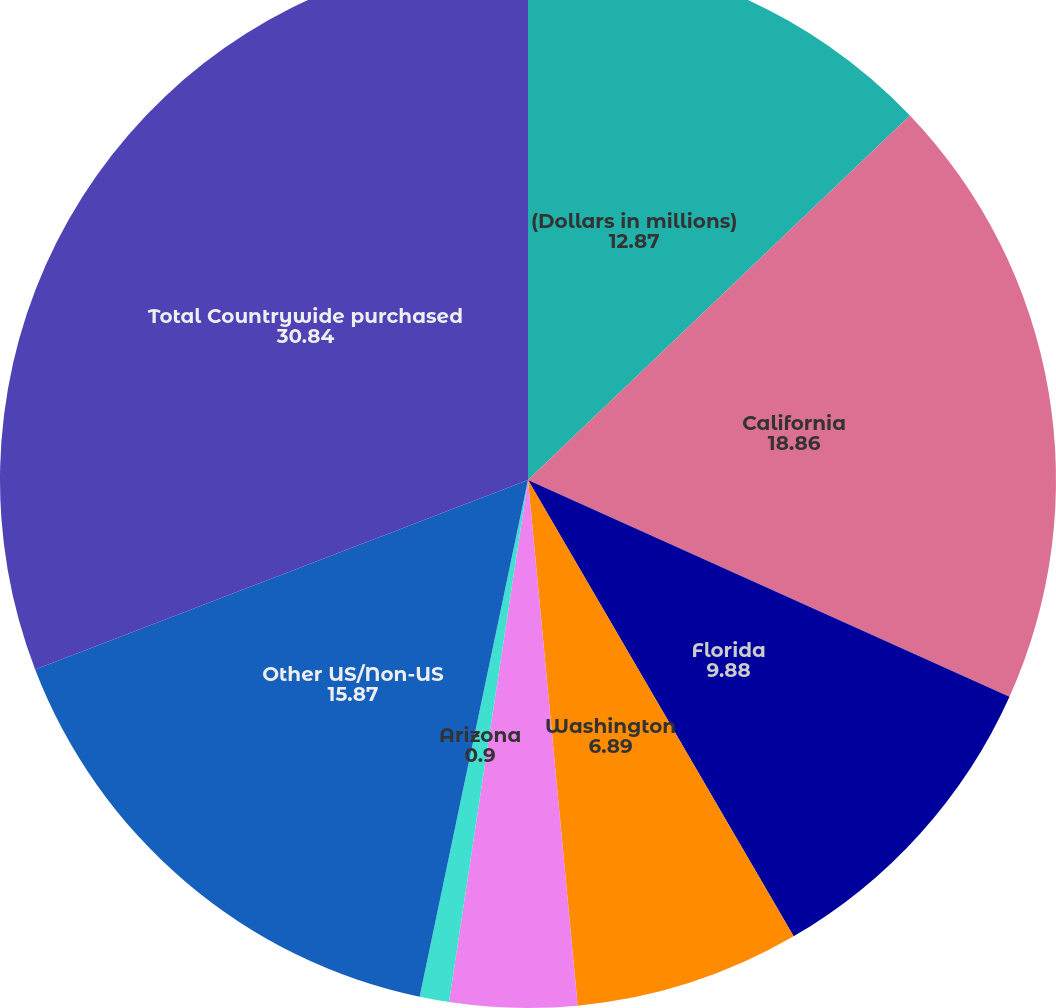Convert chart to OTSL. <chart><loc_0><loc_0><loc_500><loc_500><pie_chart><fcel>(Dollars in millions)<fcel>California<fcel>Florida<fcel>Washington<fcel>Virginia<fcel>Arizona<fcel>Other US/Non-US<fcel>Total Countrywide purchased<nl><fcel>12.87%<fcel>18.86%<fcel>9.88%<fcel>6.89%<fcel>3.89%<fcel>0.9%<fcel>15.87%<fcel>30.84%<nl></chart> 